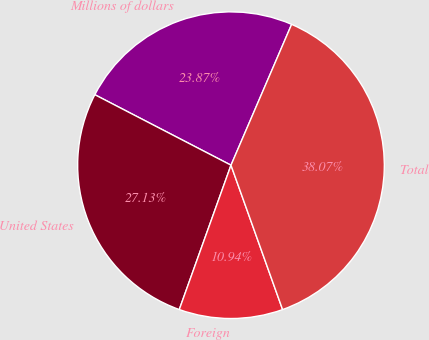Convert chart. <chart><loc_0><loc_0><loc_500><loc_500><pie_chart><fcel>Millions of dollars<fcel>United States<fcel>Foreign<fcel>Total<nl><fcel>23.87%<fcel>27.13%<fcel>10.94%<fcel>38.07%<nl></chart> 